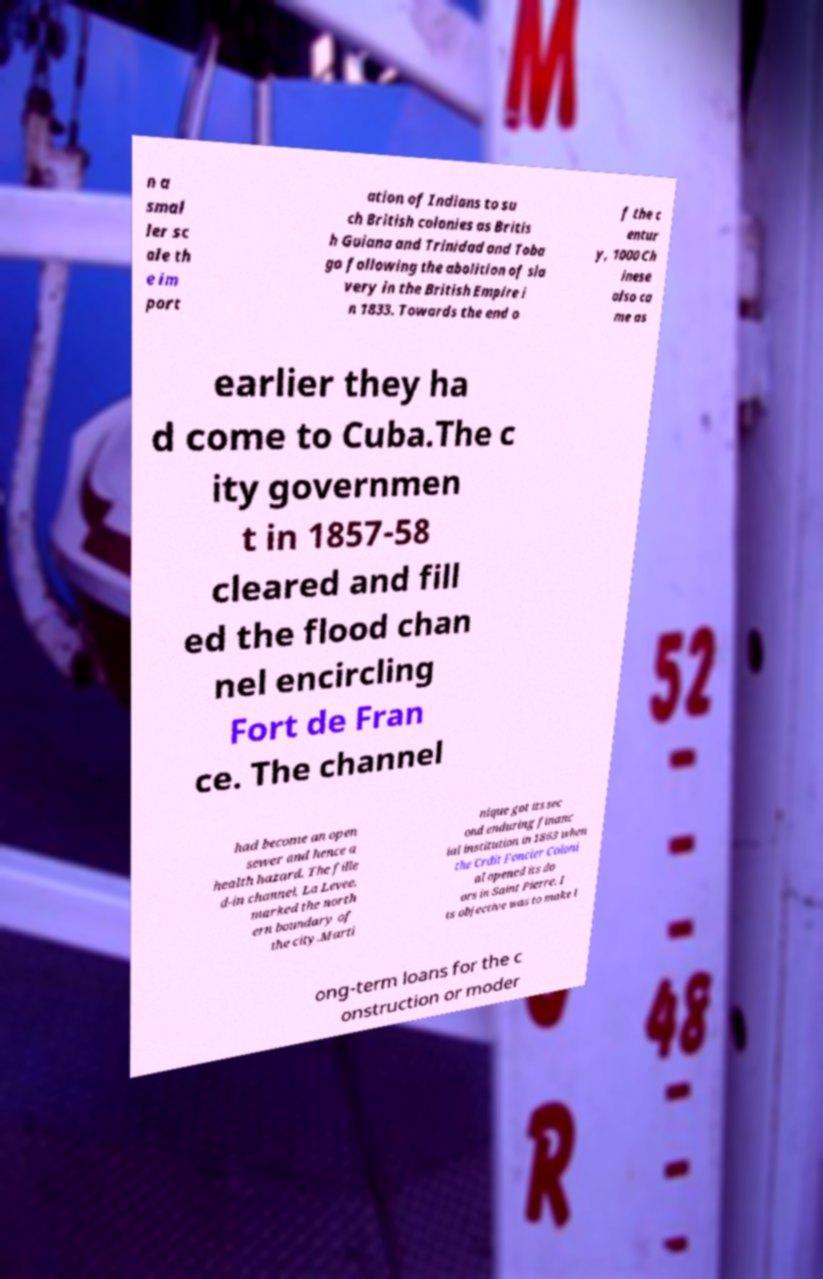Please identify and transcribe the text found in this image. n a smal ler sc ale th e im port ation of Indians to su ch British colonies as Britis h Guiana and Trinidad and Toba go following the abolition of sla very in the British Empire i n 1833. Towards the end o f the c entur y, 1000 Ch inese also ca me as earlier they ha d come to Cuba.The c ity governmen t in 1857-58 cleared and fill ed the flood chan nel encircling Fort de Fran ce. The channel had become an open sewer and hence a health hazard. The fille d-in channel, La Levee, marked the north ern boundary of the city.Marti nique got its sec ond enduring financ ial institution in 1863 when the Crdit Foncier Coloni al opened its do ors in Saint Pierre. I ts objective was to make l ong-term loans for the c onstruction or moder 